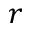Convert formula to latex. <formula><loc_0><loc_0><loc_500><loc_500>r</formula> 